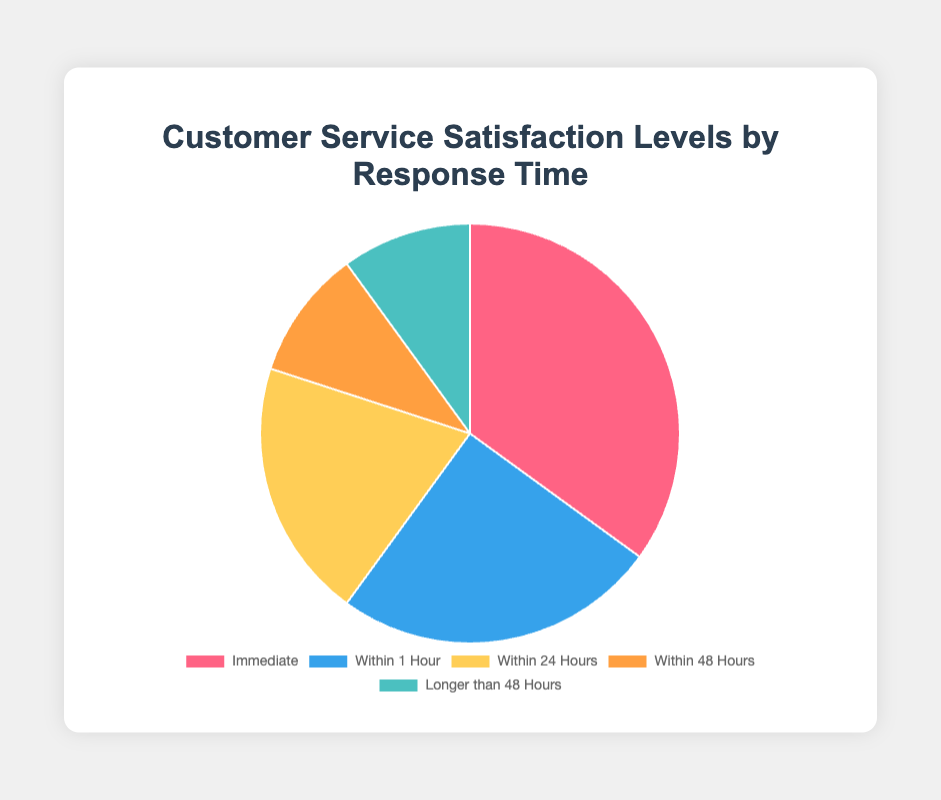What percentage of customers were satisfied with immediate response times? The segment labeled "Immediate" indicates the proportion of customers satisfied within that response time. According to the data, this segment is 35%.
Answer: 35% What is the combined satisfaction percentage for responses within 1 hour and within 24 hours? Sum the percentages for "Within 1 Hour" (25%) and "Within 24 Hours" (20%). So, 25% + 20% = 45%.
Answer: 45% Which response time category has the lowest satisfaction percentage? The satisfaction percentages are 35%, 25%, 20%, 10%, and 10%. "Within 48 Hours" and "Longer than 48 Hours" both have the lowest at 10%.
Answer: Within 48 Hours, Longer than 48 Hours How much higher is the satisfaction percentage for immediate responses compared to responses within 48 hours? The satisfaction percentage for immediate responses is 35%, and for responses within 48 hours, it is 10%. The difference is 35% - 10% = 25%.
Answer: 25% What is the average satisfaction percentage for response times of “Within 24 Hours” and “Within 48 Hours”? The satisfaction percentages for "Within 24 Hours" and "Within 48 Hours" are 20% and 10%, respectively. The average is (20% + 10%) / 2 = 15%.
Answer: 15% Which response time category has a higher satisfaction percentage: "Within 1 Hour" or "Within 24 Hours"? The satisfaction percentage for "Within 1 Hour" is 25%, and for "Within 24 Hours" is 20%. 25% is higher than 20%.
Answer: Within 1 Hour What is the sum of the satisfaction percentages for responses taking longer than 24 hours? Sum the percentages for "Within 48 Hours" (10%) and "Longer than 48 Hours" (10%). So, 10% + 10% = 20%.
Answer: 20% What is the most common satisfaction level response time based on the data? The largest segment in the pie chart represents the highest satisfaction level, which is labeled "Immediate" with 35%.
Answer: Immediate What is the total satisfaction percentage for all given response times? Sum all the provided percentages: 35% + 25% + 20% + 10% + 10% = 100%.
Answer: 100% 